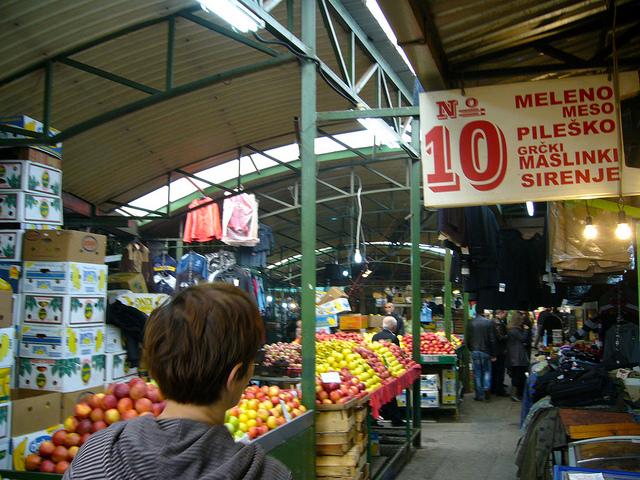What does the word in red say?
Quick response, please. Meleno. Is this a picture of a market?
Give a very brief answer. Yes. What number can be seen in this picture?
Keep it brief. 10. What language is on the sign?
Write a very short answer. Spanish. 